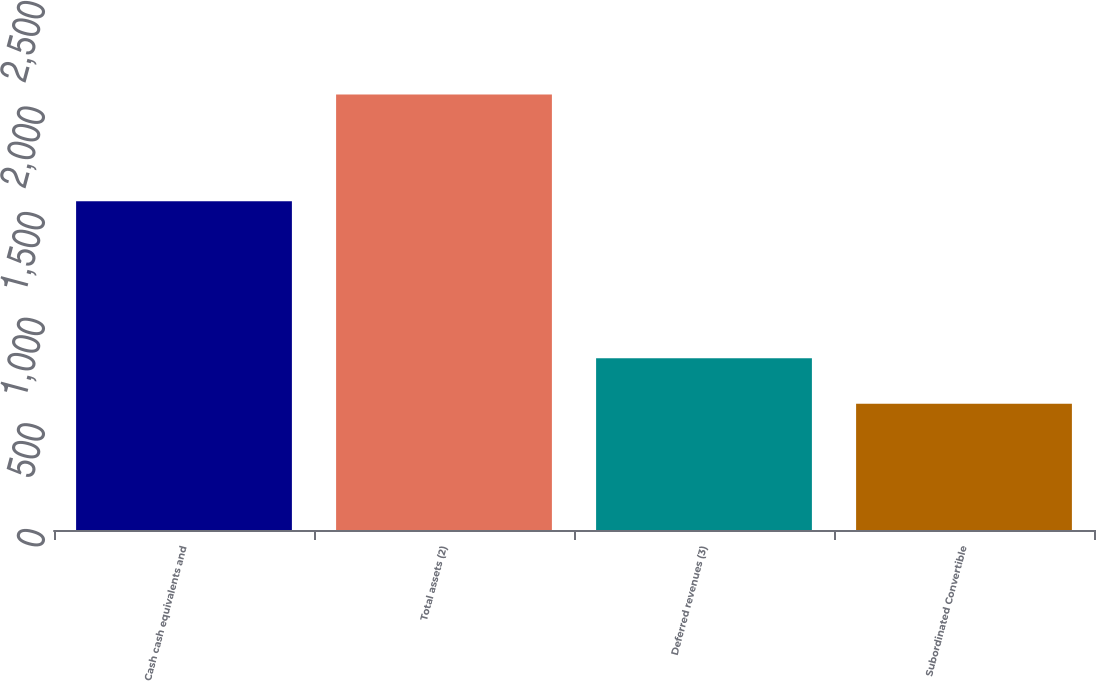Convert chart. <chart><loc_0><loc_0><loc_500><loc_500><bar_chart><fcel>Cash cash equivalents and<fcel>Total assets (2)<fcel>Deferred revenues (3)<fcel>Subordinated Convertible<nl><fcel>1556<fcel>2062<fcel>813<fcel>598<nl></chart> 